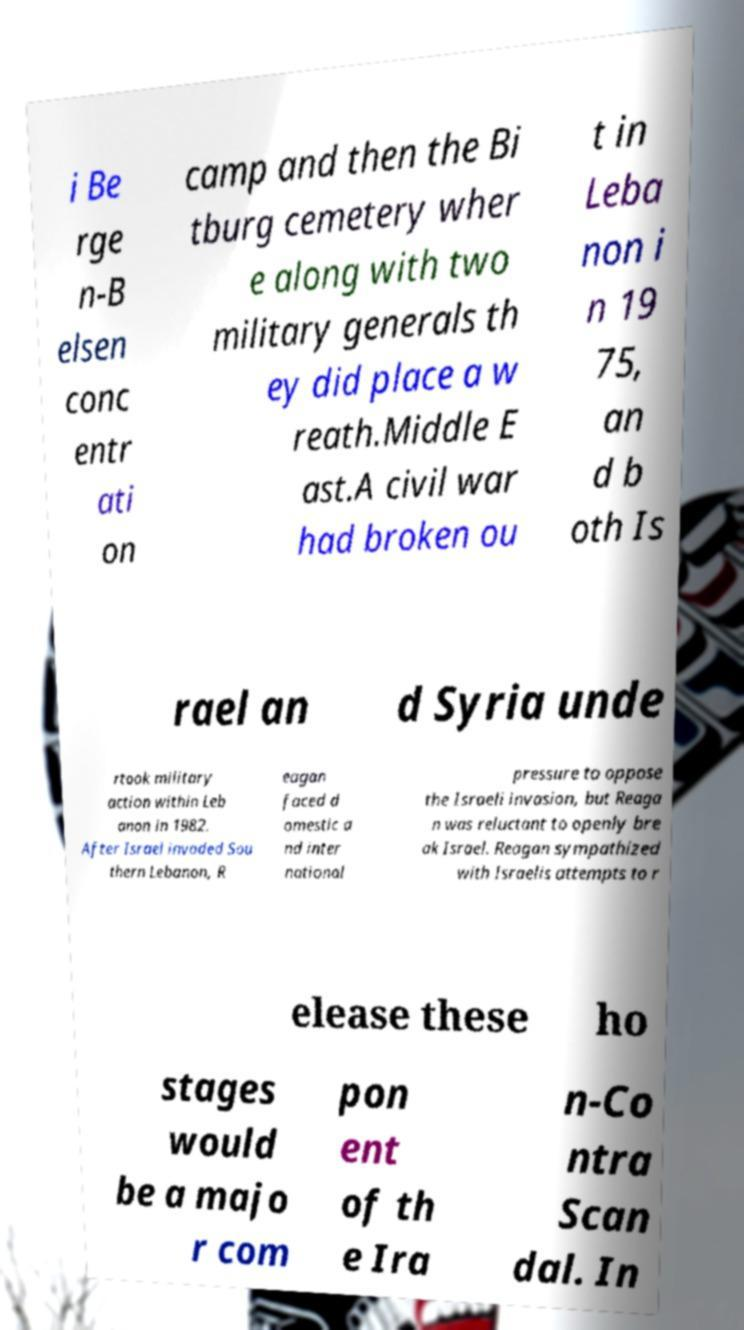Please identify and transcribe the text found in this image. i Be rge n-B elsen conc entr ati on camp and then the Bi tburg cemetery wher e along with two military generals th ey did place a w reath.Middle E ast.A civil war had broken ou t in Leba non i n 19 75, an d b oth Is rael an d Syria unde rtook military action within Leb anon in 1982. After Israel invaded Sou thern Lebanon, R eagan faced d omestic a nd inter national pressure to oppose the Israeli invasion, but Reaga n was reluctant to openly bre ak Israel. Reagan sympathized with Israelis attempts to r elease these ho stages would be a majo r com pon ent of th e Ira n-Co ntra Scan dal. In 